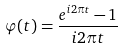Convert formula to latex. <formula><loc_0><loc_0><loc_500><loc_500>\varphi ( t ) = \frac { e ^ { i 2 \pi t } - 1 } { i 2 \pi t }</formula> 